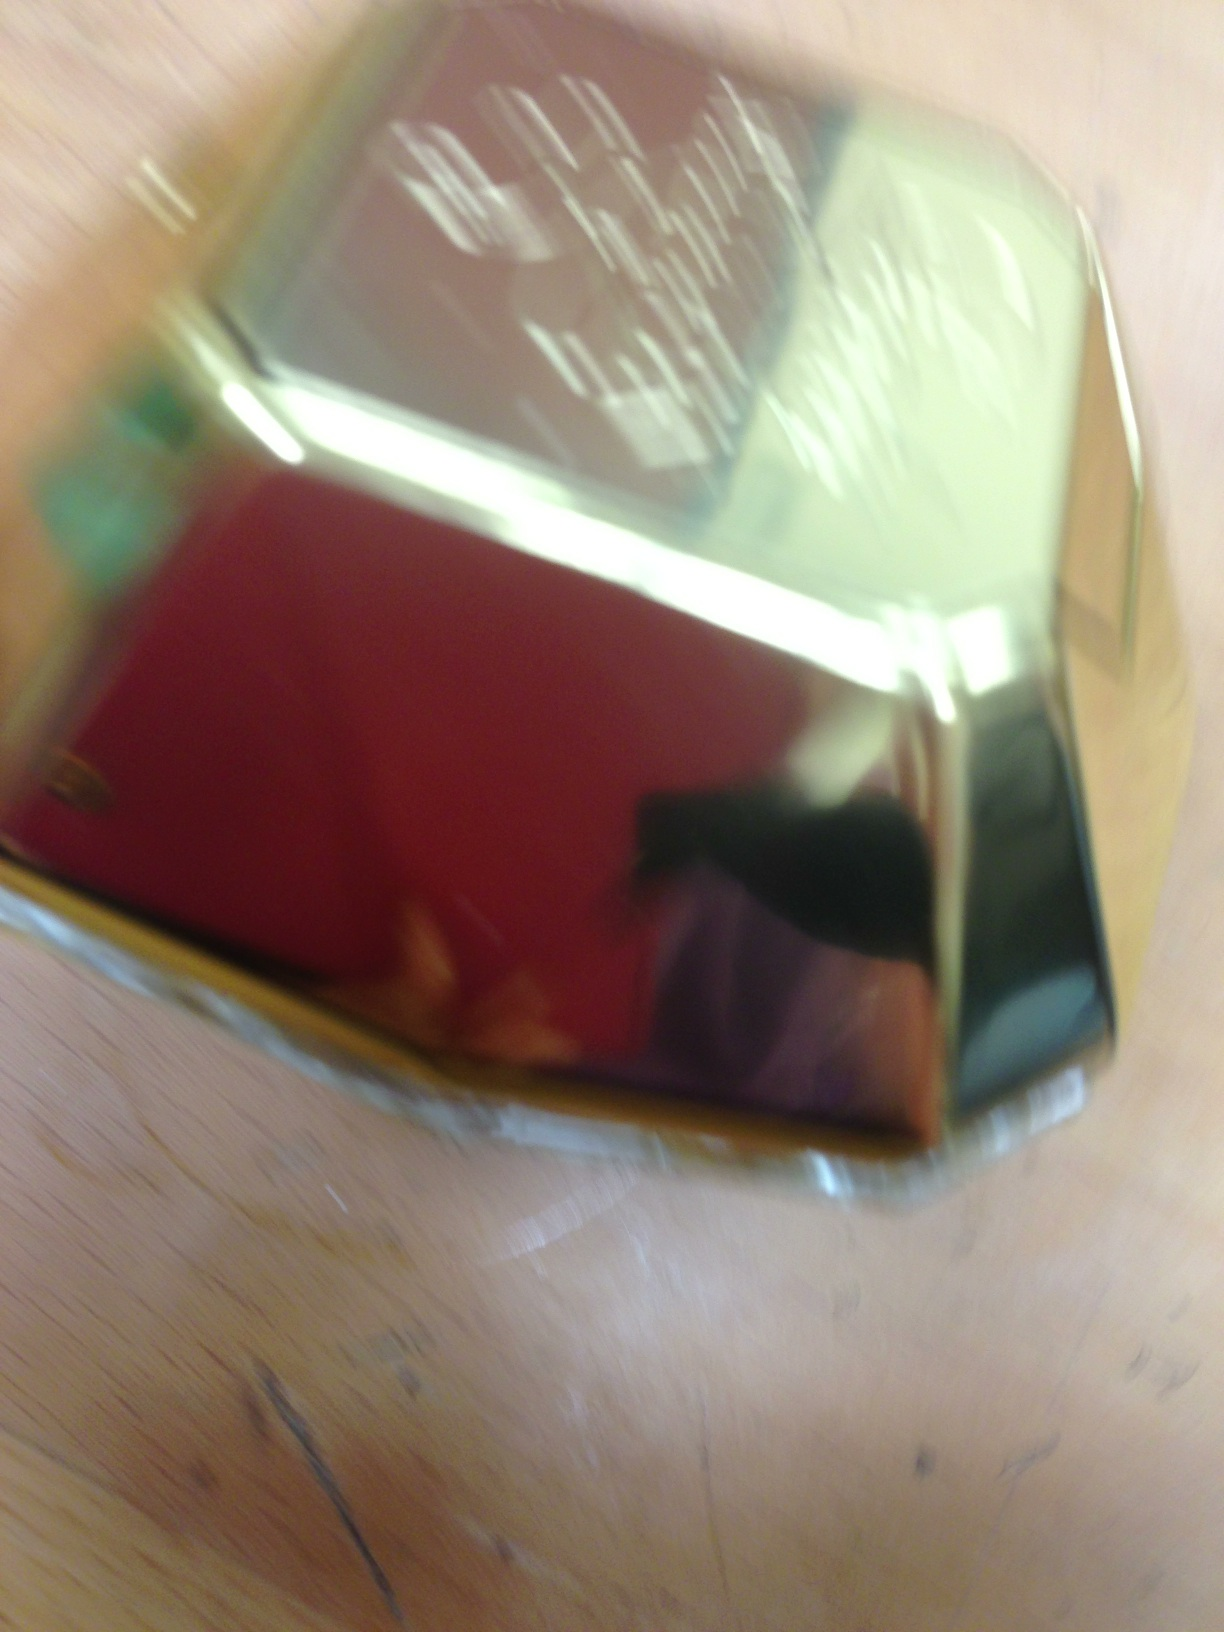Imagine a scenario where this perfume bottle is found in a treasure chest. Describe the story behind it. In a time long forgotten, this perfume bottle adorned the vanity of a legendary aristocrat. It was a gift from a distant land, crafted by the finest artisans who infused rare and precious essences into every drop. As years passed, it was hidden away in a grand chest, waiting to be uncovered as a pristine relic of a bygone era—its scent a whisper of lost opulence and romance. 